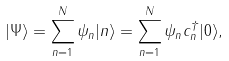<formula> <loc_0><loc_0><loc_500><loc_500>| \Psi \rangle = \sum _ { n = 1 } ^ { N } \psi _ { n } | n \rangle = \sum _ { n = 1 } ^ { N } \psi _ { n } c _ { n } ^ { \dagger } | 0 \rangle ,</formula> 